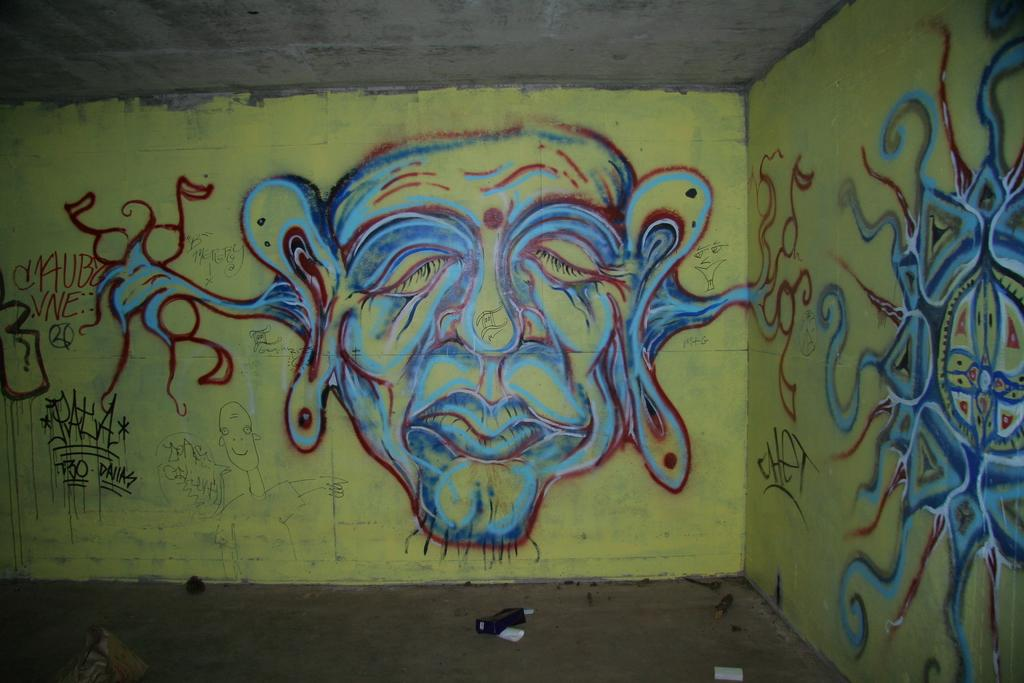What is depicted in the painting in the image? There is a painting of a woman in the image. What can be seen on the walls in the image? There is text on the walls in the image. What is on the floor in the image? There are objects on the floor in the image. What type of worm can be seen crawling on the woman's shirt in the image? There is no worm or shirt present in the image; it features a painting of a woman and text on the walls. 